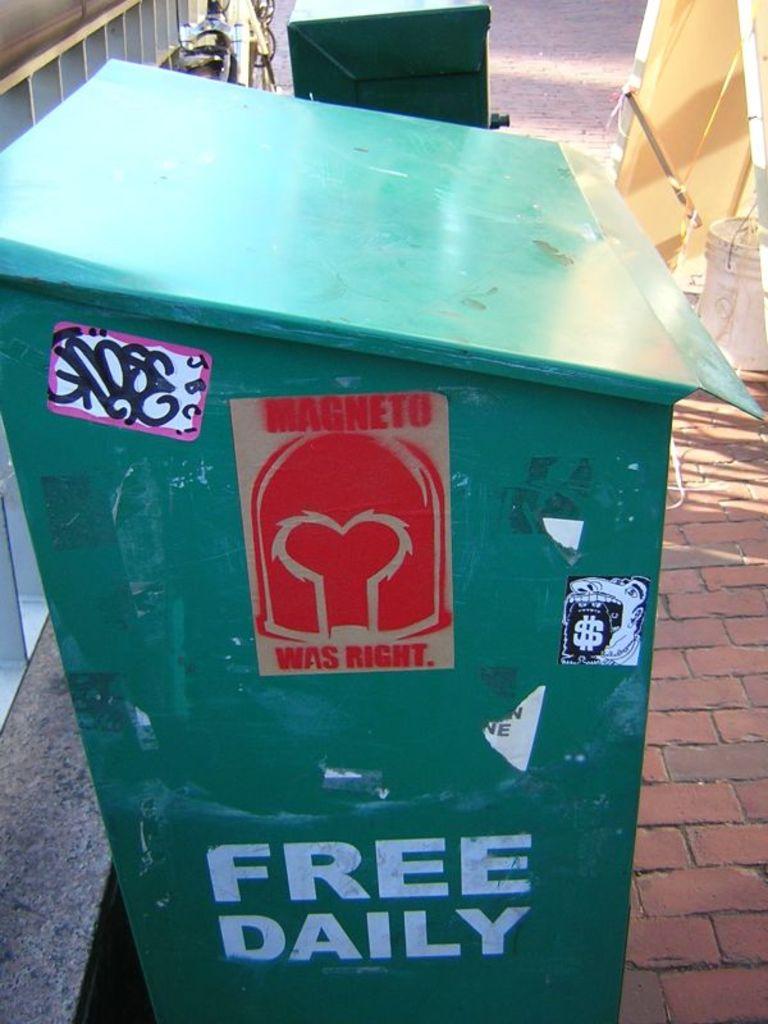Who was right?
Ensure brevity in your answer.  Magneto. What is wrote below free?
Give a very brief answer. Daily. 